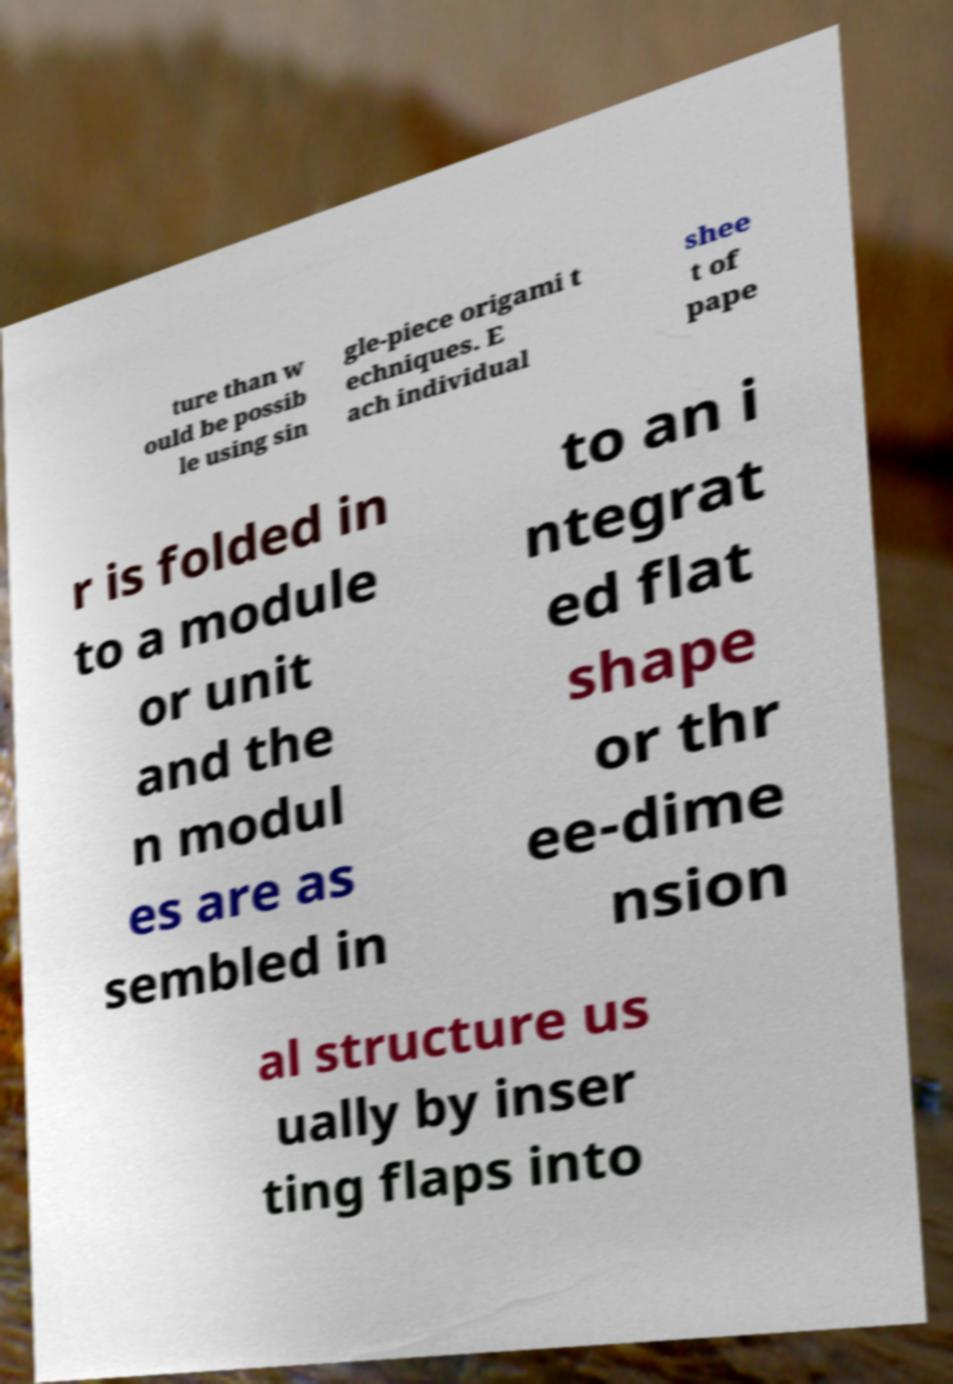I need the written content from this picture converted into text. Can you do that? ture than w ould be possib le using sin gle-piece origami t echniques. E ach individual shee t of pape r is folded in to a module or unit and the n modul es are as sembled in to an i ntegrat ed flat shape or thr ee-dime nsion al structure us ually by inser ting flaps into 